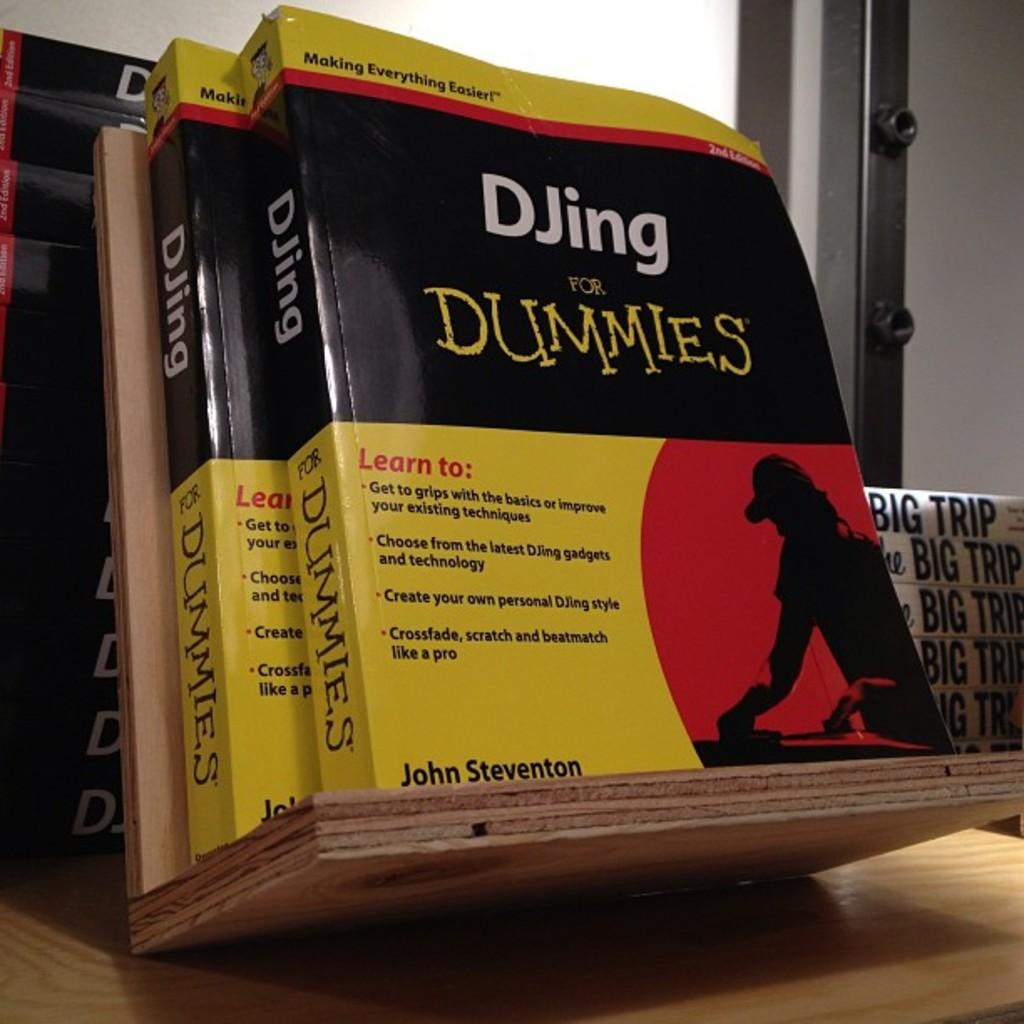Provide a one-sentence caption for the provided image. Two books called DJing for Dummies by John Steventon are displayed. 